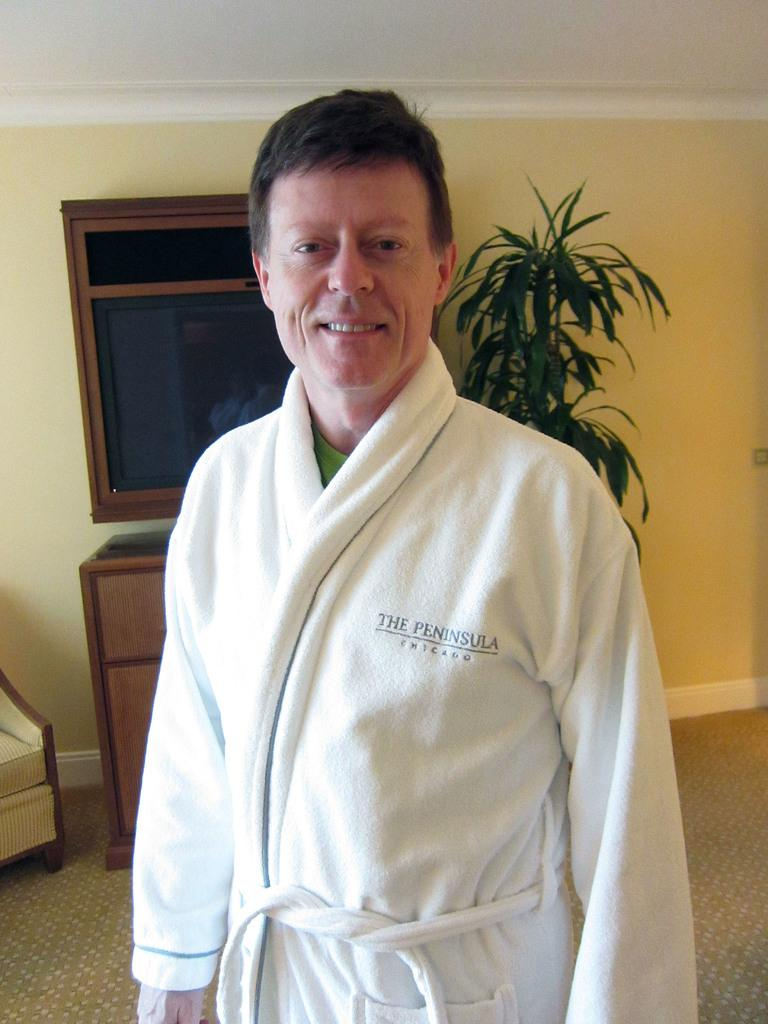<image>
Write a terse but informative summary of the picture. A man wearing a robe with The Peninsula Chicago on it. 